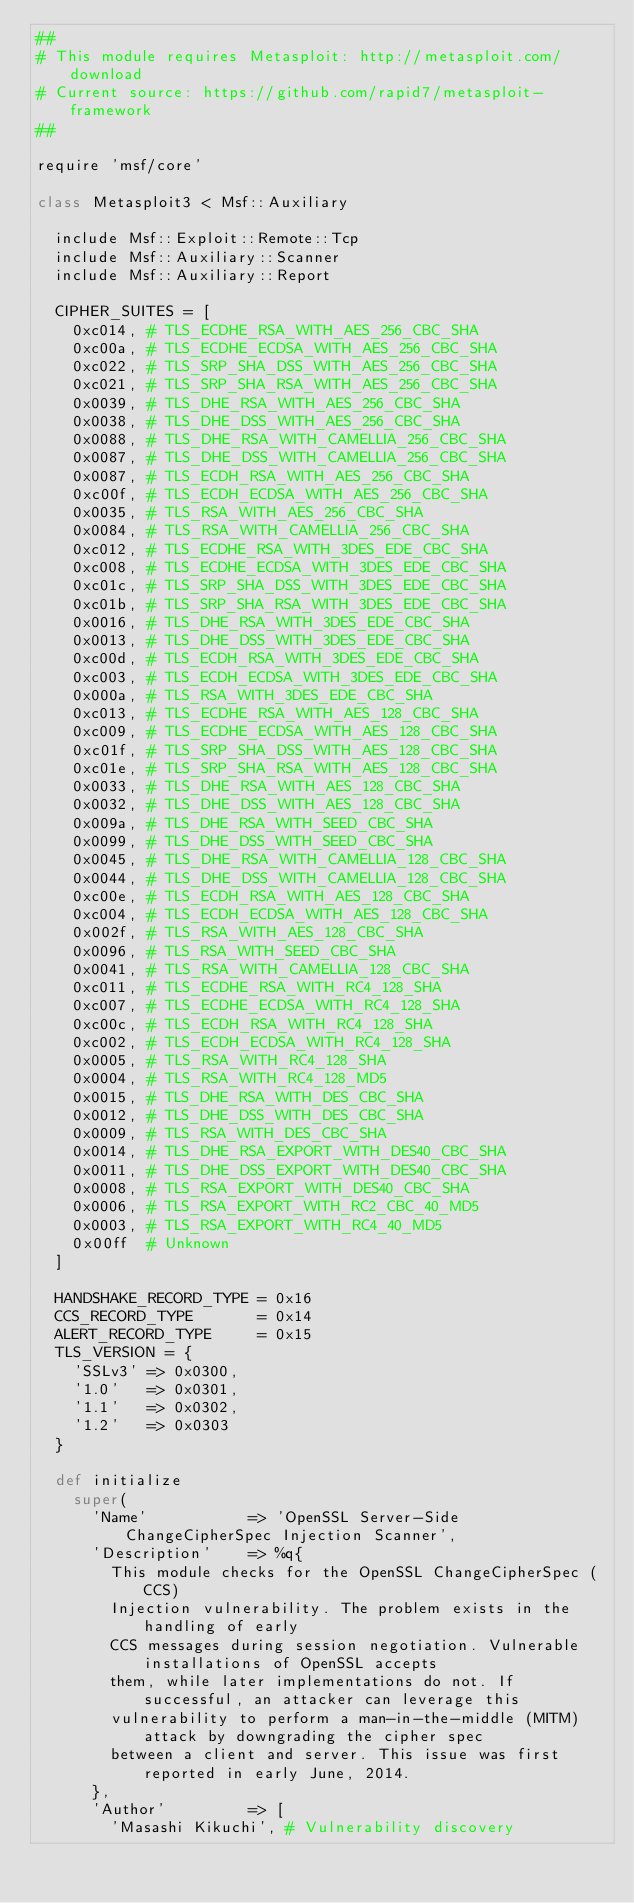<code> <loc_0><loc_0><loc_500><loc_500><_Ruby_>##
# This module requires Metasploit: http://metasploit.com/download
# Current source: https://github.com/rapid7/metasploit-framework
##

require 'msf/core'

class Metasploit3 < Msf::Auxiliary

  include Msf::Exploit::Remote::Tcp
  include Msf::Auxiliary::Scanner
  include Msf::Auxiliary::Report

  CIPHER_SUITES = [
    0xc014, # TLS_ECDHE_RSA_WITH_AES_256_CBC_SHA
    0xc00a, # TLS_ECDHE_ECDSA_WITH_AES_256_CBC_SHA
    0xc022, # TLS_SRP_SHA_DSS_WITH_AES_256_CBC_SHA
    0xc021, # TLS_SRP_SHA_RSA_WITH_AES_256_CBC_SHA
    0x0039, # TLS_DHE_RSA_WITH_AES_256_CBC_SHA
    0x0038, # TLS_DHE_DSS_WITH_AES_256_CBC_SHA
    0x0088, # TLS_DHE_RSA_WITH_CAMELLIA_256_CBC_SHA
    0x0087, # TLS_DHE_DSS_WITH_CAMELLIA_256_CBC_SHA
    0x0087, # TLS_ECDH_RSA_WITH_AES_256_CBC_SHA
    0xc00f, # TLS_ECDH_ECDSA_WITH_AES_256_CBC_SHA
    0x0035, # TLS_RSA_WITH_AES_256_CBC_SHA
    0x0084, # TLS_RSA_WITH_CAMELLIA_256_CBC_SHA
    0xc012, # TLS_ECDHE_RSA_WITH_3DES_EDE_CBC_SHA
    0xc008, # TLS_ECDHE_ECDSA_WITH_3DES_EDE_CBC_SHA
    0xc01c, # TLS_SRP_SHA_DSS_WITH_3DES_EDE_CBC_SHA
    0xc01b, # TLS_SRP_SHA_RSA_WITH_3DES_EDE_CBC_SHA
    0x0016, # TLS_DHE_RSA_WITH_3DES_EDE_CBC_SHA
    0x0013, # TLS_DHE_DSS_WITH_3DES_EDE_CBC_SHA
    0xc00d, # TLS_ECDH_RSA_WITH_3DES_EDE_CBC_SHA
    0xc003, # TLS_ECDH_ECDSA_WITH_3DES_EDE_CBC_SHA
    0x000a, # TLS_RSA_WITH_3DES_EDE_CBC_SHA
    0xc013, # TLS_ECDHE_RSA_WITH_AES_128_CBC_SHA
    0xc009, # TLS_ECDHE_ECDSA_WITH_AES_128_CBC_SHA
    0xc01f, # TLS_SRP_SHA_DSS_WITH_AES_128_CBC_SHA
    0xc01e, # TLS_SRP_SHA_RSA_WITH_AES_128_CBC_SHA
    0x0033, # TLS_DHE_RSA_WITH_AES_128_CBC_SHA
    0x0032, # TLS_DHE_DSS_WITH_AES_128_CBC_SHA
    0x009a, # TLS_DHE_RSA_WITH_SEED_CBC_SHA
    0x0099, # TLS_DHE_DSS_WITH_SEED_CBC_SHA
    0x0045, # TLS_DHE_RSA_WITH_CAMELLIA_128_CBC_SHA
    0x0044, # TLS_DHE_DSS_WITH_CAMELLIA_128_CBC_SHA
    0xc00e, # TLS_ECDH_RSA_WITH_AES_128_CBC_SHA
    0xc004, # TLS_ECDH_ECDSA_WITH_AES_128_CBC_SHA
    0x002f, # TLS_RSA_WITH_AES_128_CBC_SHA
    0x0096, # TLS_RSA_WITH_SEED_CBC_SHA
    0x0041, # TLS_RSA_WITH_CAMELLIA_128_CBC_SHA
    0xc011, # TLS_ECDHE_RSA_WITH_RC4_128_SHA
    0xc007, # TLS_ECDHE_ECDSA_WITH_RC4_128_SHA
    0xc00c, # TLS_ECDH_RSA_WITH_RC4_128_SHA
    0xc002, # TLS_ECDH_ECDSA_WITH_RC4_128_SHA
    0x0005, # TLS_RSA_WITH_RC4_128_SHA
    0x0004, # TLS_RSA_WITH_RC4_128_MD5
    0x0015, # TLS_DHE_RSA_WITH_DES_CBC_SHA
    0x0012, # TLS_DHE_DSS_WITH_DES_CBC_SHA
    0x0009, # TLS_RSA_WITH_DES_CBC_SHA
    0x0014, # TLS_DHE_RSA_EXPORT_WITH_DES40_CBC_SHA
    0x0011, # TLS_DHE_DSS_EXPORT_WITH_DES40_CBC_SHA
    0x0008, # TLS_RSA_EXPORT_WITH_DES40_CBC_SHA
    0x0006, # TLS_RSA_EXPORT_WITH_RC2_CBC_40_MD5
    0x0003, # TLS_RSA_EXPORT_WITH_RC4_40_MD5
    0x00ff  # Unknown
  ]

  HANDSHAKE_RECORD_TYPE = 0x16
  CCS_RECORD_TYPE       = 0x14
  ALERT_RECORD_TYPE     = 0x15
  TLS_VERSION = {
    'SSLv3' => 0x0300,
    '1.0'   => 0x0301,
    '1.1'   => 0x0302,
    '1.2'   => 0x0303
  }

  def initialize
    super(
      'Name'           => 'OpenSSL Server-Side ChangeCipherSpec Injection Scanner',
      'Description'    => %q{
        This module checks for the OpenSSL ChangeCipherSpec (CCS)
        Injection vulnerability. The problem exists in the handling of early
        CCS messages during session negotiation. Vulnerable installations of OpenSSL accepts
        them, while later implementations do not. If successful, an attacker can leverage this
        vulnerability to perform a man-in-the-middle (MITM) attack by downgrading the cipher spec
        between a client and server. This issue was first reported in early June, 2014.
      },
      'Author'         => [
        'Masashi Kikuchi', # Vulnerability discovery</code> 